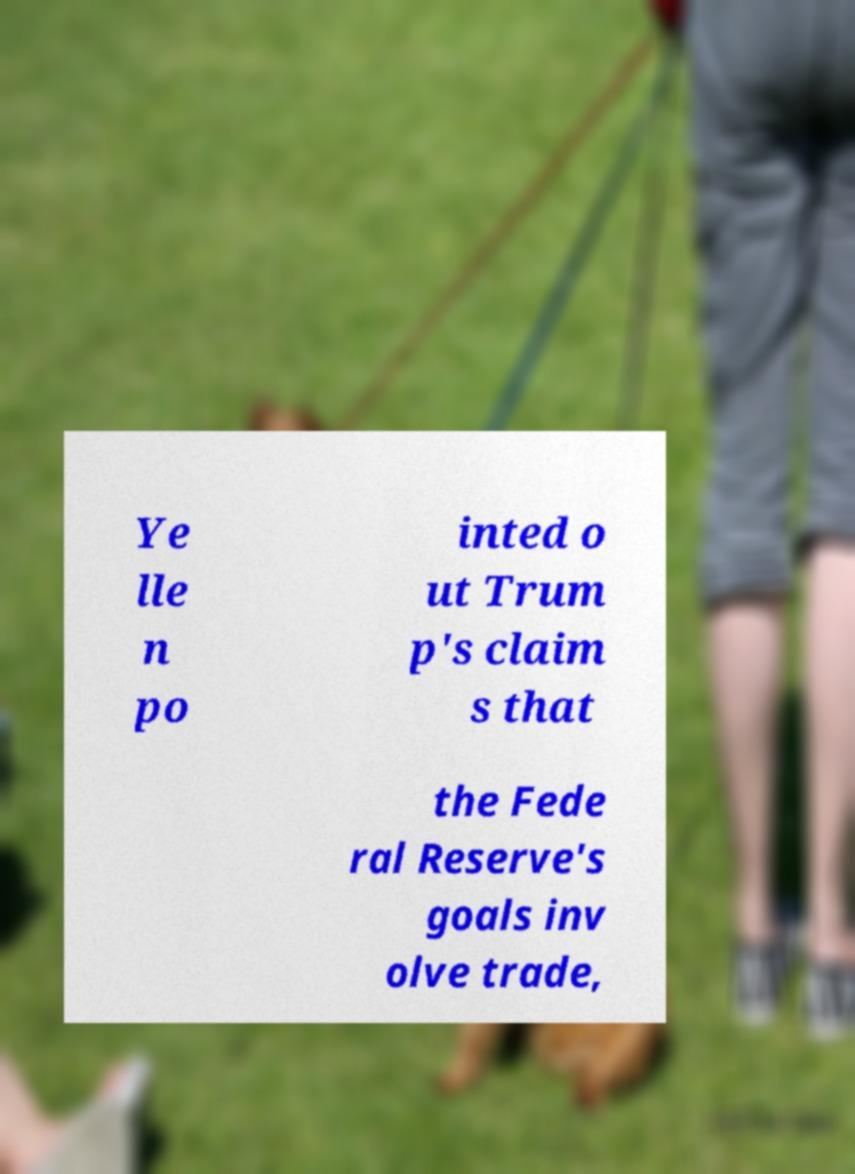I need the written content from this picture converted into text. Can you do that? Ye lle n po inted o ut Trum p's claim s that the Fede ral Reserve's goals inv olve trade, 